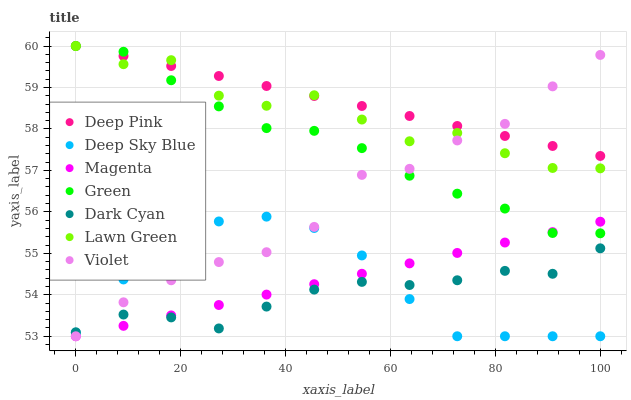Does Dark Cyan have the minimum area under the curve?
Answer yes or no. Yes. Does Deep Pink have the maximum area under the curve?
Answer yes or no. Yes. Does Green have the minimum area under the curve?
Answer yes or no. No. Does Green have the maximum area under the curve?
Answer yes or no. No. Is Deep Pink the smoothest?
Answer yes or no. Yes. Is Lawn Green the roughest?
Answer yes or no. Yes. Is Green the smoothest?
Answer yes or no. No. Is Green the roughest?
Answer yes or no. No. Does Deep Sky Blue have the lowest value?
Answer yes or no. Yes. Does Green have the lowest value?
Answer yes or no. No. Does Green have the highest value?
Answer yes or no. Yes. Does Deep Sky Blue have the highest value?
Answer yes or no. No. Is Dark Cyan less than Green?
Answer yes or no. Yes. Is Lawn Green greater than Magenta?
Answer yes or no. Yes. Does Dark Cyan intersect Deep Sky Blue?
Answer yes or no. Yes. Is Dark Cyan less than Deep Sky Blue?
Answer yes or no. No. Is Dark Cyan greater than Deep Sky Blue?
Answer yes or no. No. Does Dark Cyan intersect Green?
Answer yes or no. No. 